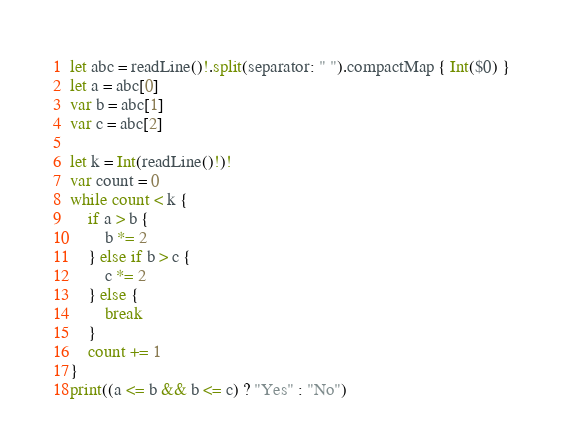<code> <loc_0><loc_0><loc_500><loc_500><_Swift_>let abc = readLine()!.split(separator: " ").compactMap { Int($0) }
let a = abc[0]
var b = abc[1]
var c = abc[2]

let k = Int(readLine()!)!
var count = 0
while count < k {
    if a > b {
        b *= 2
    } else if b > c {
        c *= 2
    } else {
        break
    }
    count += 1
}
print((a <= b && b <= c) ? "Yes" : "No")
</code> 